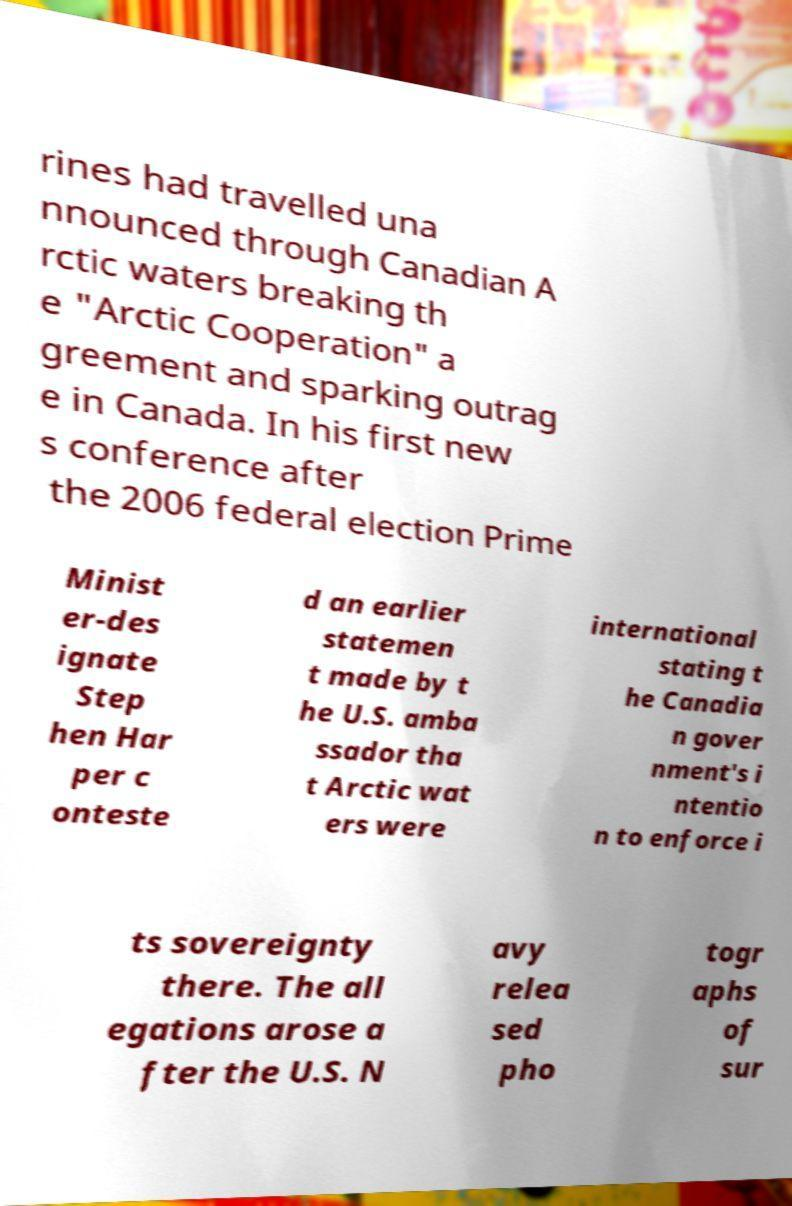Could you assist in decoding the text presented in this image and type it out clearly? rines had travelled una nnounced through Canadian A rctic waters breaking th e "Arctic Cooperation" a greement and sparking outrag e in Canada. In his first new s conference after the 2006 federal election Prime Minist er-des ignate Step hen Har per c onteste d an earlier statemen t made by t he U.S. amba ssador tha t Arctic wat ers were international stating t he Canadia n gover nment's i ntentio n to enforce i ts sovereignty there. The all egations arose a fter the U.S. N avy relea sed pho togr aphs of sur 